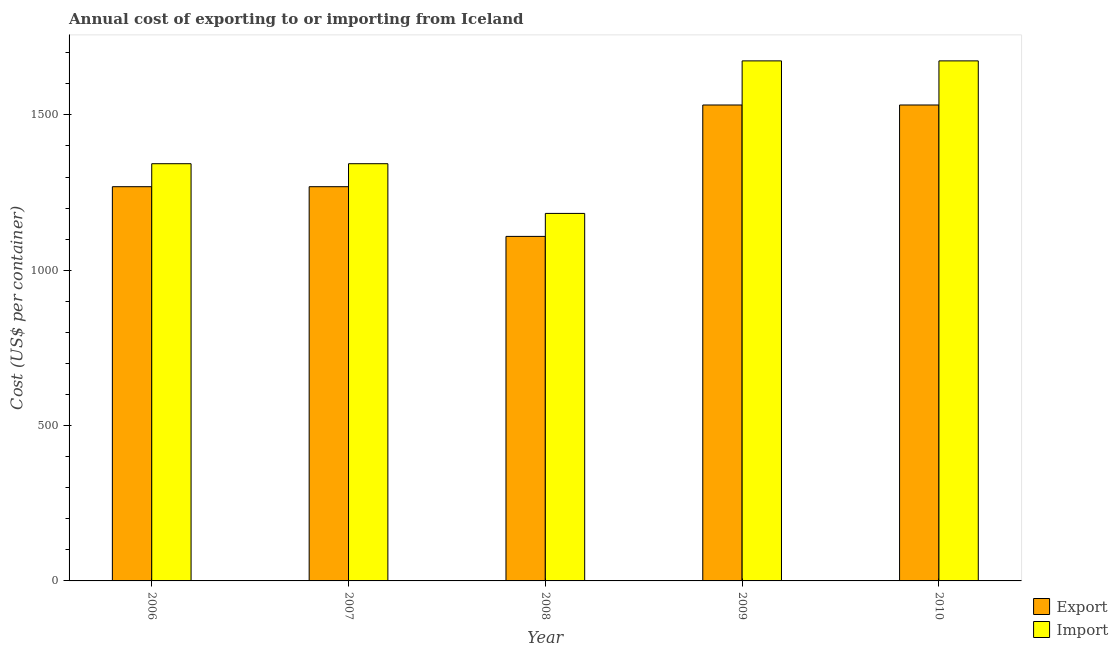Are the number of bars on each tick of the X-axis equal?
Make the answer very short. Yes. What is the label of the 1st group of bars from the left?
Make the answer very short. 2006. What is the export cost in 2008?
Your response must be concise. 1109. Across all years, what is the maximum export cost?
Your response must be concise. 1532. Across all years, what is the minimum export cost?
Keep it short and to the point. 1109. In which year was the import cost minimum?
Provide a short and direct response. 2008. What is the total import cost in the graph?
Your response must be concise. 7217. What is the difference between the export cost in 2007 and that in 2009?
Your answer should be compact. -263. What is the difference between the export cost in 2006 and the import cost in 2008?
Keep it short and to the point. 160. What is the average export cost per year?
Keep it short and to the point. 1342.2. In the year 2006, what is the difference between the export cost and import cost?
Your answer should be very brief. 0. In how many years, is the export cost greater than 800 US$?
Give a very brief answer. 5. What is the ratio of the export cost in 2008 to that in 2010?
Provide a succinct answer. 0.72. What is the difference between the highest and the second highest export cost?
Provide a succinct answer. 0. What is the difference between the highest and the lowest export cost?
Provide a short and direct response. 423. Is the sum of the import cost in 2008 and 2009 greater than the maximum export cost across all years?
Offer a very short reply. Yes. What does the 2nd bar from the left in 2010 represents?
Your answer should be very brief. Import. What does the 2nd bar from the right in 2006 represents?
Your answer should be compact. Export. How many bars are there?
Provide a short and direct response. 10. Are all the bars in the graph horizontal?
Provide a short and direct response. No. What is the difference between two consecutive major ticks on the Y-axis?
Offer a very short reply. 500. Are the values on the major ticks of Y-axis written in scientific E-notation?
Make the answer very short. No. Does the graph contain grids?
Provide a short and direct response. No. Where does the legend appear in the graph?
Ensure brevity in your answer.  Bottom right. What is the title of the graph?
Offer a terse response. Annual cost of exporting to or importing from Iceland. What is the label or title of the Y-axis?
Give a very brief answer. Cost (US$ per container). What is the Cost (US$ per container) in Export in 2006?
Provide a short and direct response. 1269. What is the Cost (US$ per container) of Import in 2006?
Your answer should be compact. 1343. What is the Cost (US$ per container) in Export in 2007?
Your answer should be very brief. 1269. What is the Cost (US$ per container) of Import in 2007?
Provide a succinct answer. 1343. What is the Cost (US$ per container) in Export in 2008?
Offer a very short reply. 1109. What is the Cost (US$ per container) in Import in 2008?
Ensure brevity in your answer.  1183. What is the Cost (US$ per container) in Export in 2009?
Make the answer very short. 1532. What is the Cost (US$ per container) in Import in 2009?
Offer a terse response. 1674. What is the Cost (US$ per container) of Export in 2010?
Offer a terse response. 1532. What is the Cost (US$ per container) of Import in 2010?
Keep it short and to the point. 1674. Across all years, what is the maximum Cost (US$ per container) of Export?
Your answer should be very brief. 1532. Across all years, what is the maximum Cost (US$ per container) in Import?
Offer a very short reply. 1674. Across all years, what is the minimum Cost (US$ per container) in Export?
Make the answer very short. 1109. Across all years, what is the minimum Cost (US$ per container) in Import?
Offer a terse response. 1183. What is the total Cost (US$ per container) of Export in the graph?
Keep it short and to the point. 6711. What is the total Cost (US$ per container) of Import in the graph?
Ensure brevity in your answer.  7217. What is the difference between the Cost (US$ per container) in Import in 2006 and that in 2007?
Provide a short and direct response. 0. What is the difference between the Cost (US$ per container) in Export in 2006 and that in 2008?
Ensure brevity in your answer.  160. What is the difference between the Cost (US$ per container) of Import in 2006 and that in 2008?
Keep it short and to the point. 160. What is the difference between the Cost (US$ per container) in Export in 2006 and that in 2009?
Your response must be concise. -263. What is the difference between the Cost (US$ per container) in Import in 2006 and that in 2009?
Your answer should be very brief. -331. What is the difference between the Cost (US$ per container) in Export in 2006 and that in 2010?
Offer a terse response. -263. What is the difference between the Cost (US$ per container) in Import in 2006 and that in 2010?
Keep it short and to the point. -331. What is the difference between the Cost (US$ per container) of Export in 2007 and that in 2008?
Make the answer very short. 160. What is the difference between the Cost (US$ per container) in Import in 2007 and that in 2008?
Ensure brevity in your answer.  160. What is the difference between the Cost (US$ per container) of Export in 2007 and that in 2009?
Offer a terse response. -263. What is the difference between the Cost (US$ per container) of Import in 2007 and that in 2009?
Ensure brevity in your answer.  -331. What is the difference between the Cost (US$ per container) in Export in 2007 and that in 2010?
Provide a short and direct response. -263. What is the difference between the Cost (US$ per container) of Import in 2007 and that in 2010?
Provide a short and direct response. -331. What is the difference between the Cost (US$ per container) in Export in 2008 and that in 2009?
Make the answer very short. -423. What is the difference between the Cost (US$ per container) in Import in 2008 and that in 2009?
Offer a terse response. -491. What is the difference between the Cost (US$ per container) of Export in 2008 and that in 2010?
Your response must be concise. -423. What is the difference between the Cost (US$ per container) in Import in 2008 and that in 2010?
Offer a terse response. -491. What is the difference between the Cost (US$ per container) of Export in 2009 and that in 2010?
Your answer should be compact. 0. What is the difference between the Cost (US$ per container) of Import in 2009 and that in 2010?
Your response must be concise. 0. What is the difference between the Cost (US$ per container) of Export in 2006 and the Cost (US$ per container) of Import in 2007?
Your answer should be very brief. -74. What is the difference between the Cost (US$ per container) of Export in 2006 and the Cost (US$ per container) of Import in 2009?
Make the answer very short. -405. What is the difference between the Cost (US$ per container) of Export in 2006 and the Cost (US$ per container) of Import in 2010?
Your answer should be very brief. -405. What is the difference between the Cost (US$ per container) in Export in 2007 and the Cost (US$ per container) in Import in 2009?
Offer a very short reply. -405. What is the difference between the Cost (US$ per container) of Export in 2007 and the Cost (US$ per container) of Import in 2010?
Your answer should be compact. -405. What is the difference between the Cost (US$ per container) in Export in 2008 and the Cost (US$ per container) in Import in 2009?
Your response must be concise. -565. What is the difference between the Cost (US$ per container) in Export in 2008 and the Cost (US$ per container) in Import in 2010?
Provide a short and direct response. -565. What is the difference between the Cost (US$ per container) of Export in 2009 and the Cost (US$ per container) of Import in 2010?
Your answer should be very brief. -142. What is the average Cost (US$ per container) of Export per year?
Offer a very short reply. 1342.2. What is the average Cost (US$ per container) in Import per year?
Your response must be concise. 1443.4. In the year 2006, what is the difference between the Cost (US$ per container) in Export and Cost (US$ per container) in Import?
Ensure brevity in your answer.  -74. In the year 2007, what is the difference between the Cost (US$ per container) in Export and Cost (US$ per container) in Import?
Your response must be concise. -74. In the year 2008, what is the difference between the Cost (US$ per container) in Export and Cost (US$ per container) in Import?
Your response must be concise. -74. In the year 2009, what is the difference between the Cost (US$ per container) in Export and Cost (US$ per container) in Import?
Your answer should be very brief. -142. In the year 2010, what is the difference between the Cost (US$ per container) in Export and Cost (US$ per container) in Import?
Make the answer very short. -142. What is the ratio of the Cost (US$ per container) of Export in 2006 to that in 2007?
Offer a terse response. 1. What is the ratio of the Cost (US$ per container) of Export in 2006 to that in 2008?
Provide a short and direct response. 1.14. What is the ratio of the Cost (US$ per container) of Import in 2006 to that in 2008?
Provide a succinct answer. 1.14. What is the ratio of the Cost (US$ per container) of Export in 2006 to that in 2009?
Provide a short and direct response. 0.83. What is the ratio of the Cost (US$ per container) of Import in 2006 to that in 2009?
Your answer should be very brief. 0.8. What is the ratio of the Cost (US$ per container) in Export in 2006 to that in 2010?
Offer a terse response. 0.83. What is the ratio of the Cost (US$ per container) of Import in 2006 to that in 2010?
Offer a terse response. 0.8. What is the ratio of the Cost (US$ per container) of Export in 2007 to that in 2008?
Keep it short and to the point. 1.14. What is the ratio of the Cost (US$ per container) in Import in 2007 to that in 2008?
Give a very brief answer. 1.14. What is the ratio of the Cost (US$ per container) of Export in 2007 to that in 2009?
Keep it short and to the point. 0.83. What is the ratio of the Cost (US$ per container) in Import in 2007 to that in 2009?
Keep it short and to the point. 0.8. What is the ratio of the Cost (US$ per container) in Export in 2007 to that in 2010?
Provide a succinct answer. 0.83. What is the ratio of the Cost (US$ per container) in Import in 2007 to that in 2010?
Keep it short and to the point. 0.8. What is the ratio of the Cost (US$ per container) in Export in 2008 to that in 2009?
Give a very brief answer. 0.72. What is the ratio of the Cost (US$ per container) in Import in 2008 to that in 2009?
Give a very brief answer. 0.71. What is the ratio of the Cost (US$ per container) in Export in 2008 to that in 2010?
Your response must be concise. 0.72. What is the ratio of the Cost (US$ per container) of Import in 2008 to that in 2010?
Your answer should be compact. 0.71. What is the ratio of the Cost (US$ per container) in Export in 2009 to that in 2010?
Your response must be concise. 1. What is the difference between the highest and the second highest Cost (US$ per container) of Import?
Ensure brevity in your answer.  0. What is the difference between the highest and the lowest Cost (US$ per container) of Export?
Offer a very short reply. 423. What is the difference between the highest and the lowest Cost (US$ per container) in Import?
Offer a terse response. 491. 